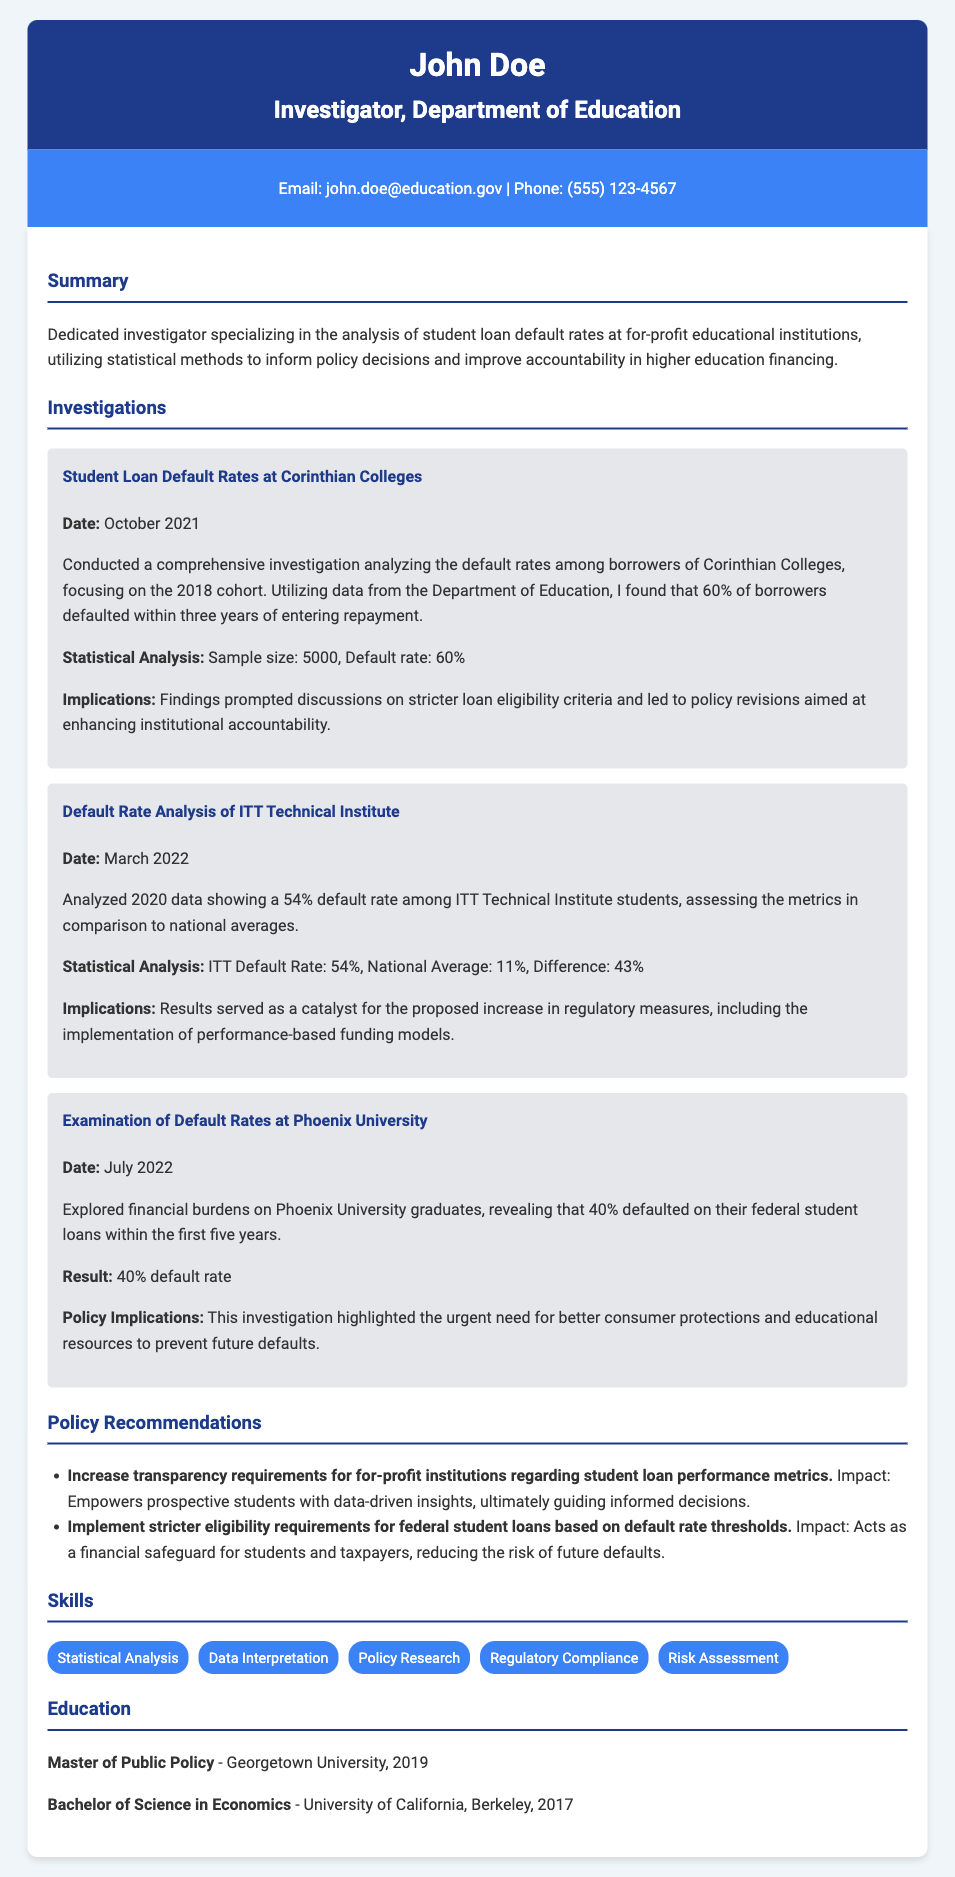What is the name of the investigator? The investigator's name is prominently stated at the beginning of the document in the header.
Answer: John Doe What is the primary focus of the investigations conducted? The summary section outlines the primary focus of the investigator's work on student loan default rates.
Answer: Student loan default rates What percentage of borrowers defaulted at Corinthian Colleges? The investigation section provides specific statistics about various institutions, including Corinthian Colleges.
Answer: 60% When was the examination of default rates at Phoenix University conducted? The date for each investigation is specified clearly in their respective sections.
Answer: July 2022 What was the default rate for ITT Technical Institute in comparison to the national average? The investigation details both the ITT default rate and the national average to highlight the difference.
Answer: 43% What are two policy recommendations made in the CV? The policy recommendations section lists specific suggestions based on the findings of the investigations.
Answer: Increase transparency requirements, Implement stricter eligibility requirements How many students were in the sample size for the Corinthian Colleges investigation? The investigation section includes details about the sample size used for analysis.
Answer: 5000 What degree did John Doe receive in 2019? The education section indicates the degrees obtained by the investigator along with their completion dates.
Answer: Master of Public Policy What is the statistical analysis result for Phoenix University’s default rate? The investigation provides clear results for various institutions including Phoenix University.
Answer: 40% default rate 